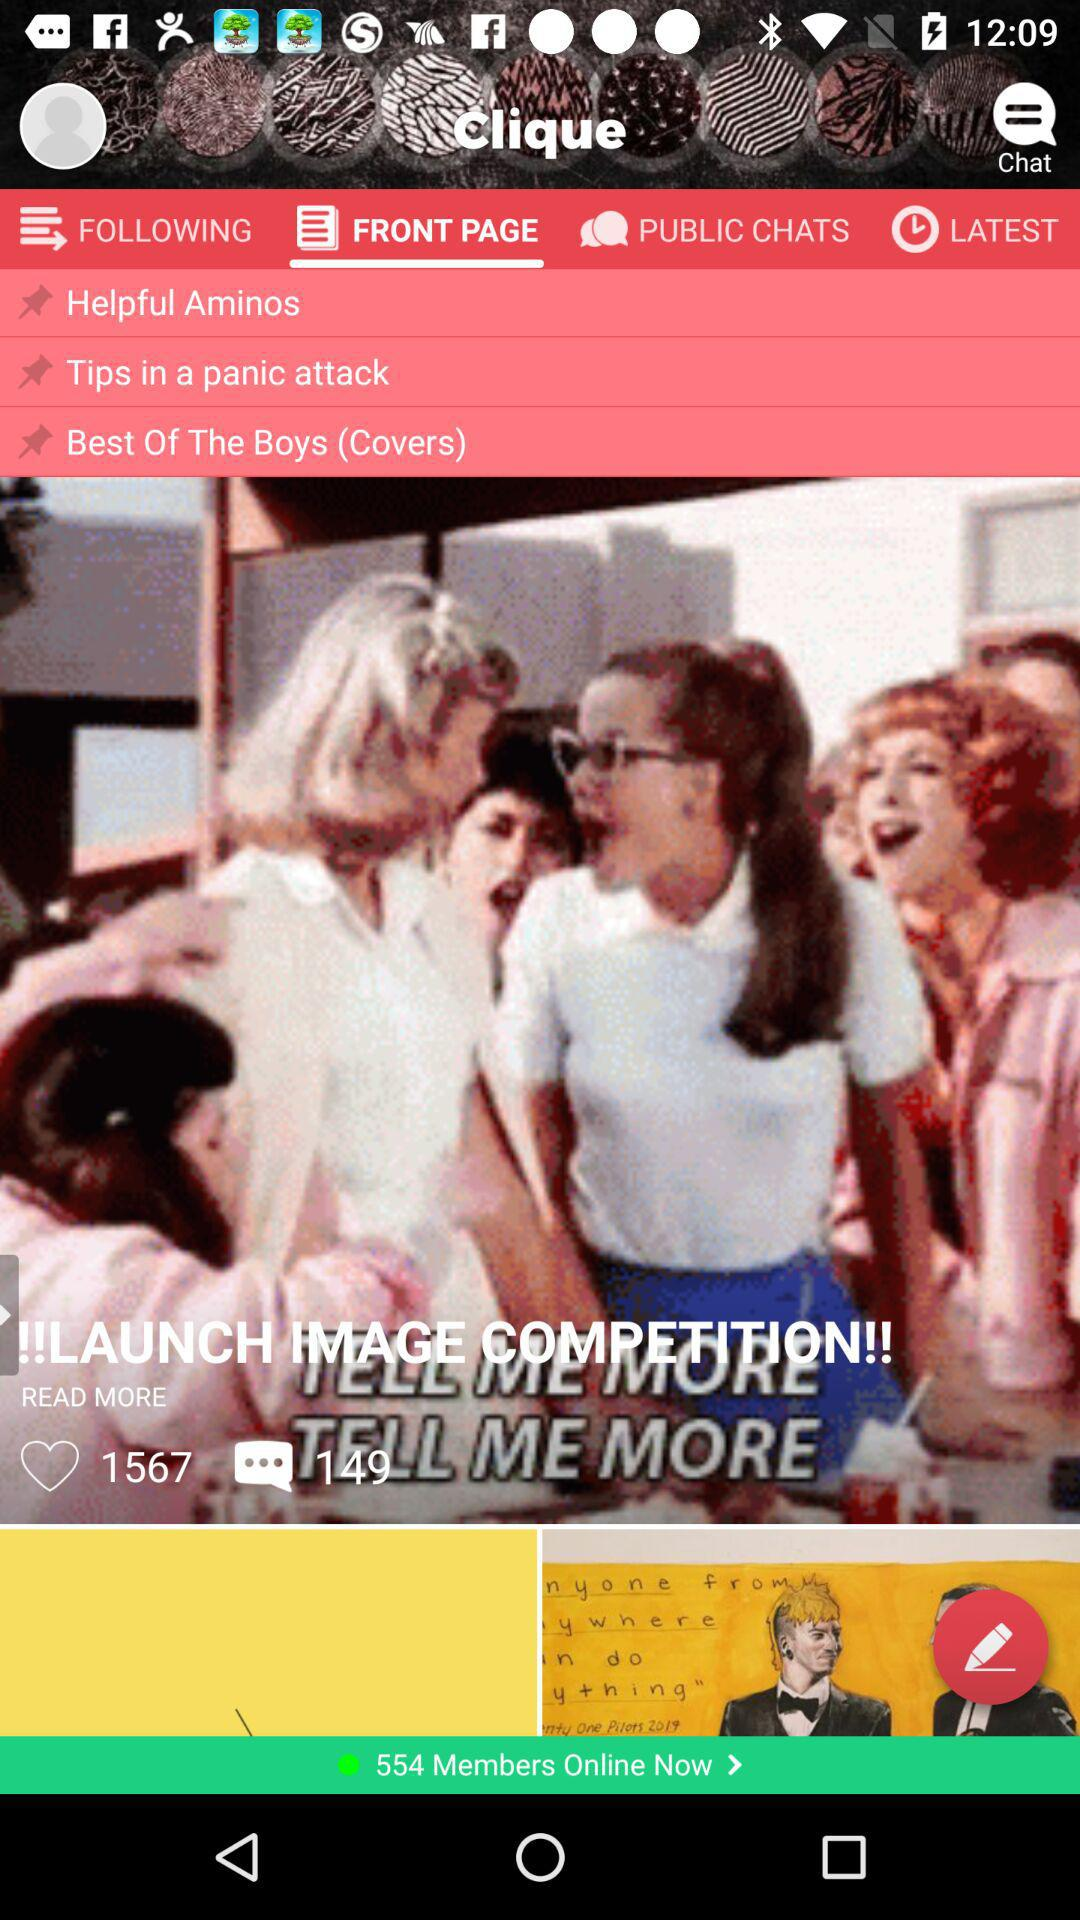Which tab is selected right now? The selected tab is "FRONT PAGE". 